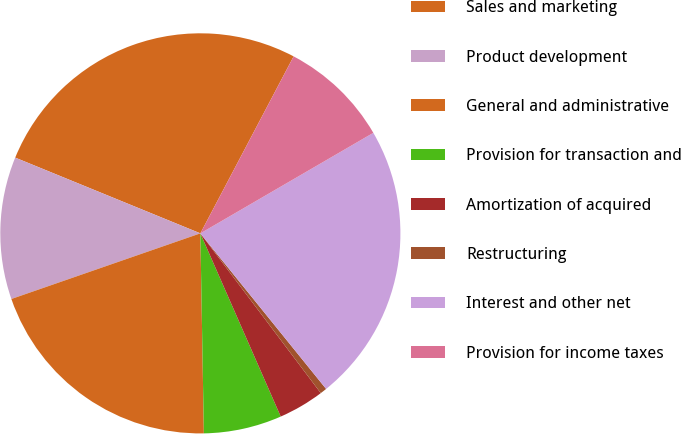<chart> <loc_0><loc_0><loc_500><loc_500><pie_chart><fcel>Sales and marketing<fcel>Product development<fcel>General and administrative<fcel>Provision for transaction and<fcel>Amortization of acquired<fcel>Restructuring<fcel>Interest and other net<fcel>Provision for income taxes<nl><fcel>26.54%<fcel>11.5%<fcel>19.96%<fcel>6.3%<fcel>3.7%<fcel>0.54%<fcel>22.56%<fcel>8.9%<nl></chart> 